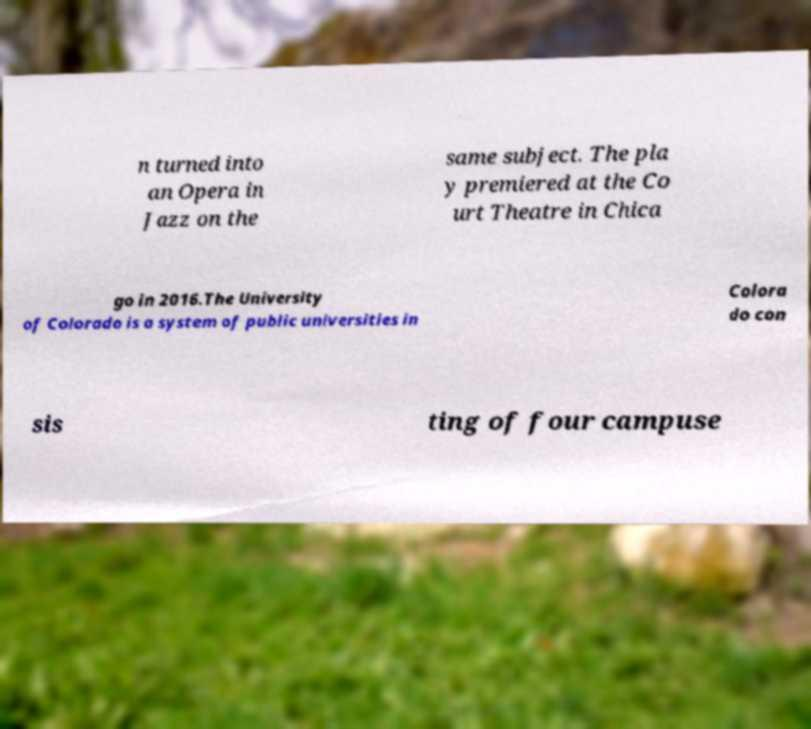Could you assist in decoding the text presented in this image and type it out clearly? n turned into an Opera in Jazz on the same subject. The pla y premiered at the Co urt Theatre in Chica go in 2016.The University of Colorado is a system of public universities in Colora do con sis ting of four campuse 